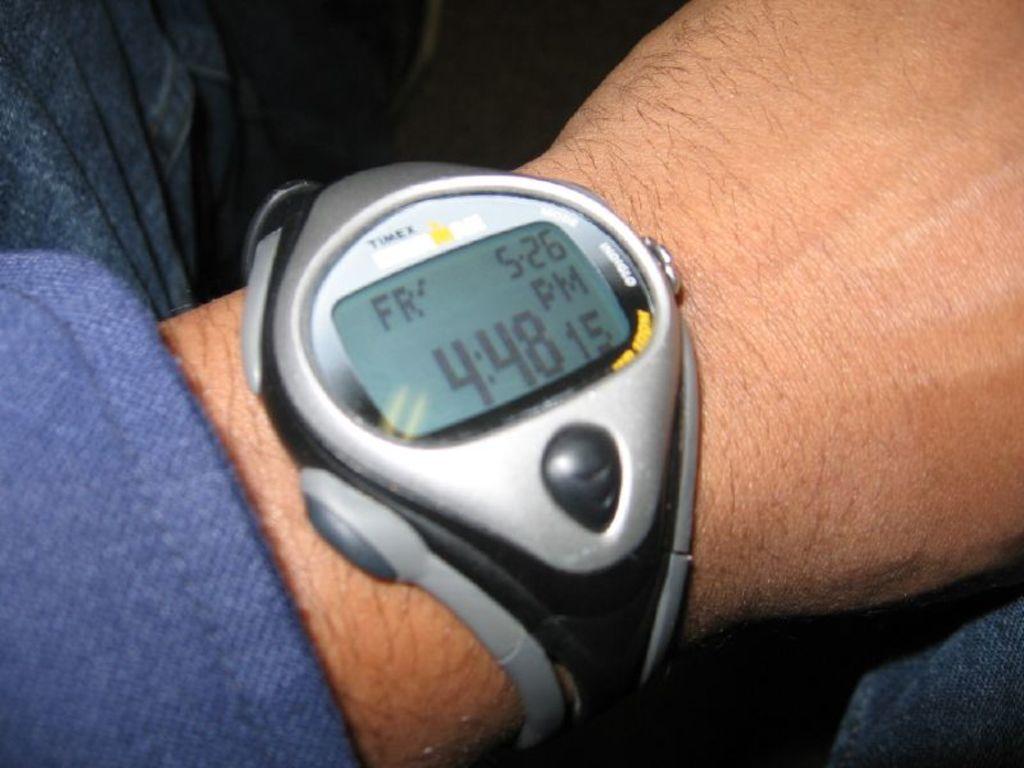What time does the watch say?
Offer a very short reply. 4:48. What day is it?
Ensure brevity in your answer.  Friday. 